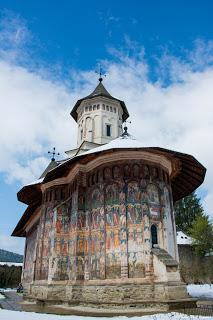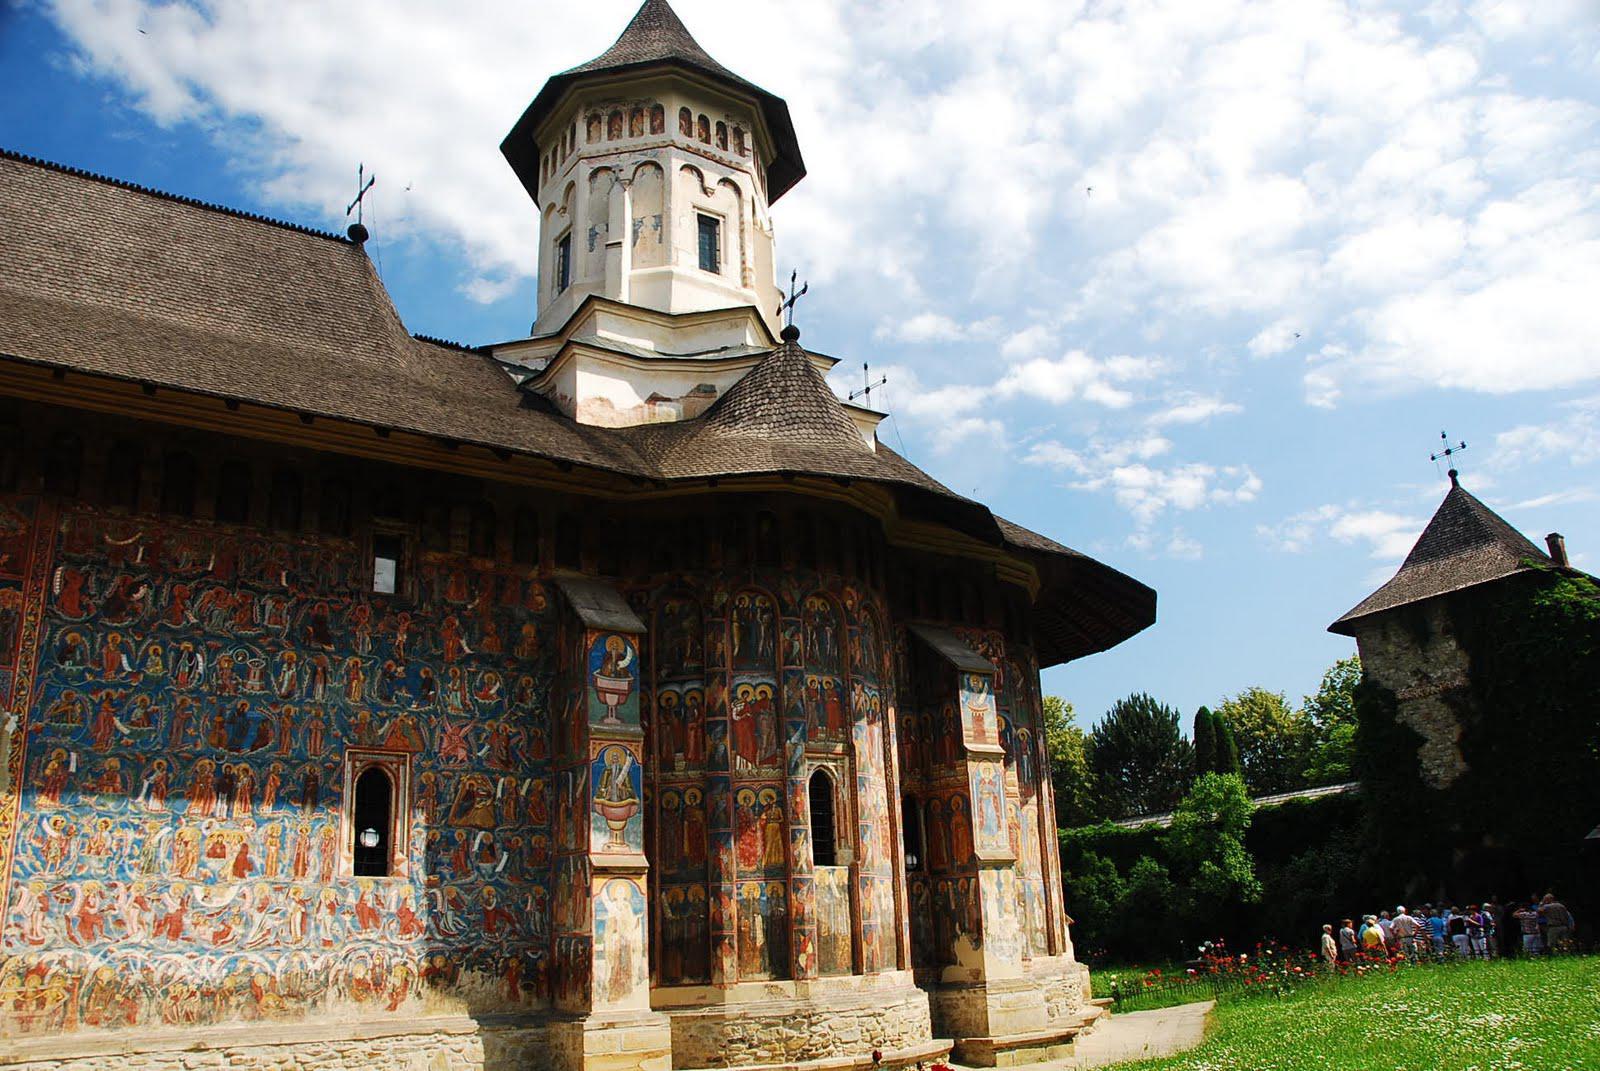The first image is the image on the left, the second image is the image on the right. For the images shown, is this caption "The left and right image contains the same number of inside churches facing north and right." true? Answer yes or no. No. The first image is the image on the left, the second image is the image on the right. Evaluate the accuracy of this statement regarding the images: "You can see a lawn surrounding the church in both images.". Is it true? Answer yes or no. No. 